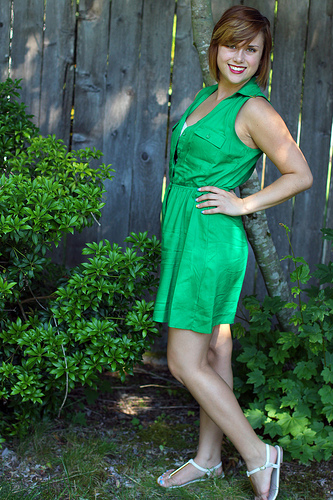<image>
Is there a woman behind the tree? No. The woman is not behind the tree. From this viewpoint, the woman appears to be positioned elsewhere in the scene. 